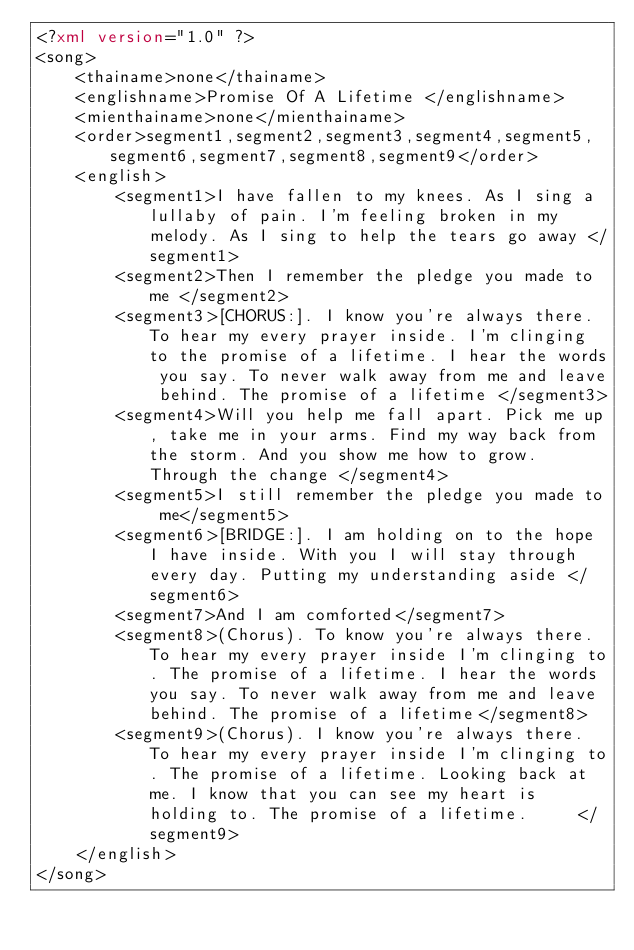<code> <loc_0><loc_0><loc_500><loc_500><_XML_><?xml version="1.0" ?>
<song>
	<thainame>none</thainame>
	<englishname>Promise Of A Lifetime </englishname>
	<mienthainame>none</mienthainame>
	<order>segment1,segment2,segment3,segment4,segment5,segment6,segment7,segment8,segment9</order>
	<english>
		<segment1>I have fallen to my knees. As I sing a lullaby of pain. I'm feeling broken in my melody. As I sing to help the tears go away </segment1>
		<segment2>Then I remember the pledge you made to me </segment2>
		<segment3>[CHORUS:]. I know you're always there. To hear my every prayer inside. I'm clinging to the promise of a lifetime. I hear the words you say. To never walk away from me and leave behind. The promise of a lifetime </segment3>
		<segment4>Will you help me fall apart. Pick me up, take me in your arms. Find my way back from the storm. And you show me how to grow. Through the change </segment4>
		<segment5>I still remember the pledge you made to me</segment5>
		<segment6>[BRIDGE:]. I am holding on to the hope I have inside. With you I will stay through every day. Putting my understanding aside </segment6>
		<segment7>And I am comforted</segment7>
		<segment8>(Chorus). To know you're always there. To hear my every prayer inside I'm clinging to. The promise of a lifetime. I hear the words you say. To never walk away from me and leave behind. The promise of a lifetime</segment8>
		<segment9>(Chorus). I know you're always there. To hear my every prayer inside I'm clinging to. The promise of a lifetime. Looking back at me. I know that you can see my heart is holding to. The promise of a lifetime.     </segment9>
	</english>
</song>
</code> 